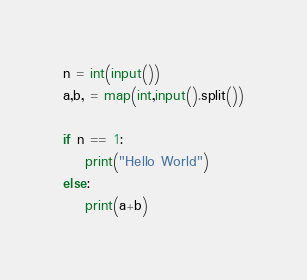Convert code to text. <code><loc_0><loc_0><loc_500><loc_500><_Python_>n = int(input())
a,b, = map(int,input().split())

if n == 1:
    print("Hello World")
else:
    print(a+b)</code> 